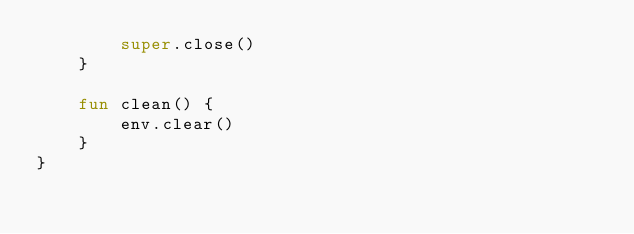Convert code to text. <code><loc_0><loc_0><loc_500><loc_500><_Kotlin_>        super.close()
    }

    fun clean() {
        env.clear()
    }
}
</code> 